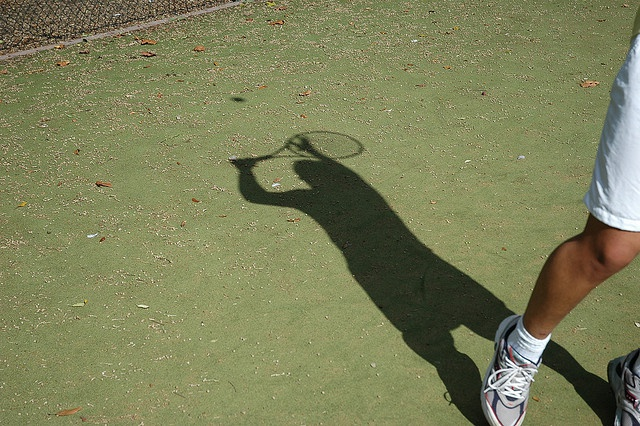Describe the objects in this image and their specific colors. I can see people in maroon, lightgray, black, gray, and darkgray tones in this image. 